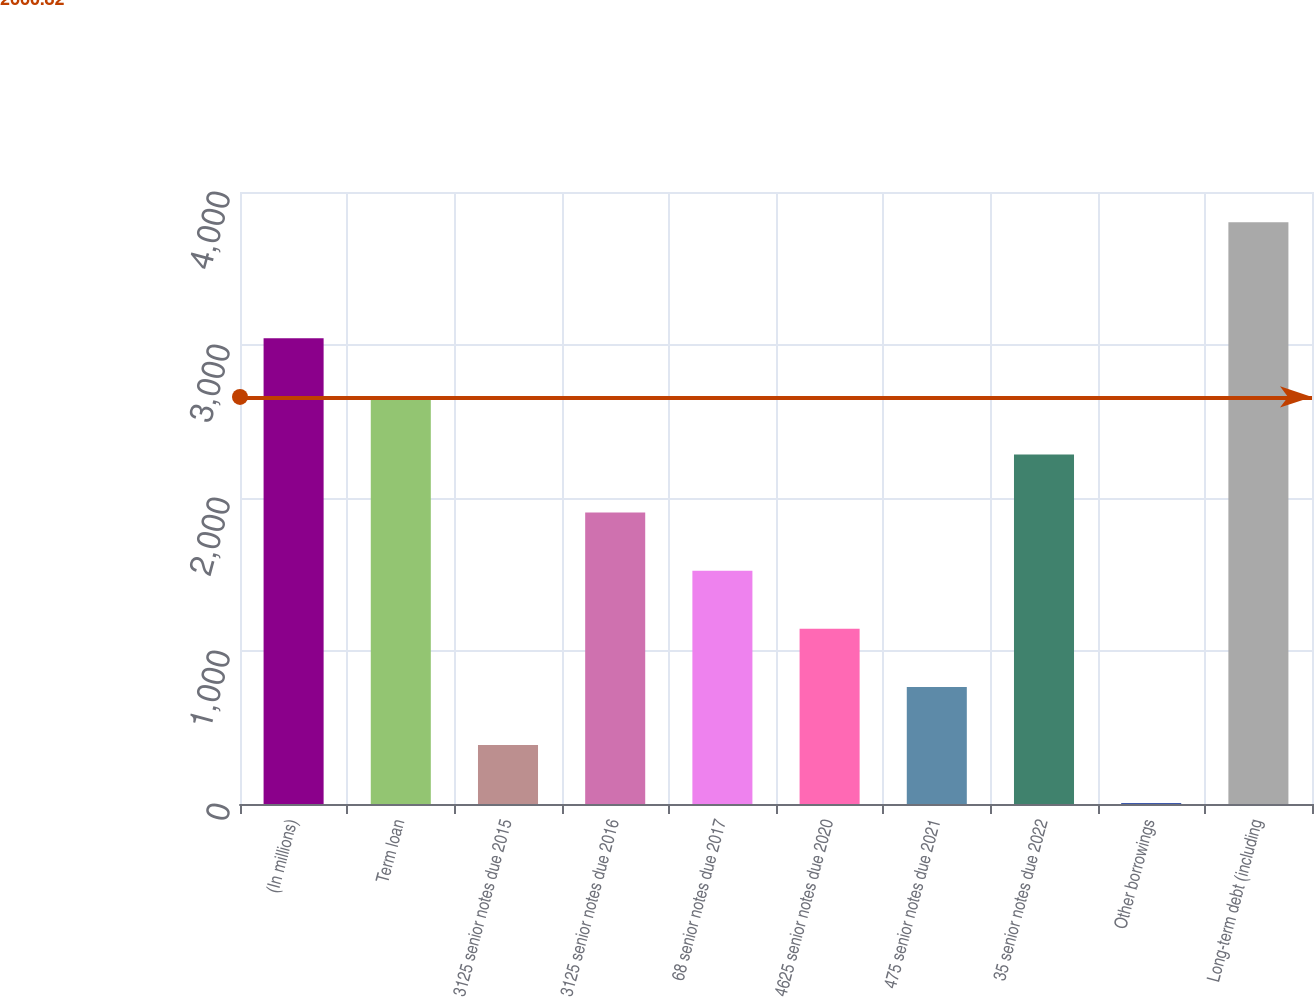Convert chart. <chart><loc_0><loc_0><loc_500><loc_500><bar_chart><fcel>(In millions)<fcel>Term loan<fcel>3125 senior notes due 2015<fcel>3125 senior notes due 2016<fcel>68 senior notes due 2017<fcel>4625 senior notes due 2020<fcel>475 senior notes due 2021<fcel>35 senior notes due 2022<fcel>Other borrowings<fcel>Long-term debt (including<nl><fcel>3043.6<fcel>2663.9<fcel>385.7<fcel>1904.5<fcel>1524.8<fcel>1145.1<fcel>765.4<fcel>2284.2<fcel>6<fcel>3803<nl></chart> 